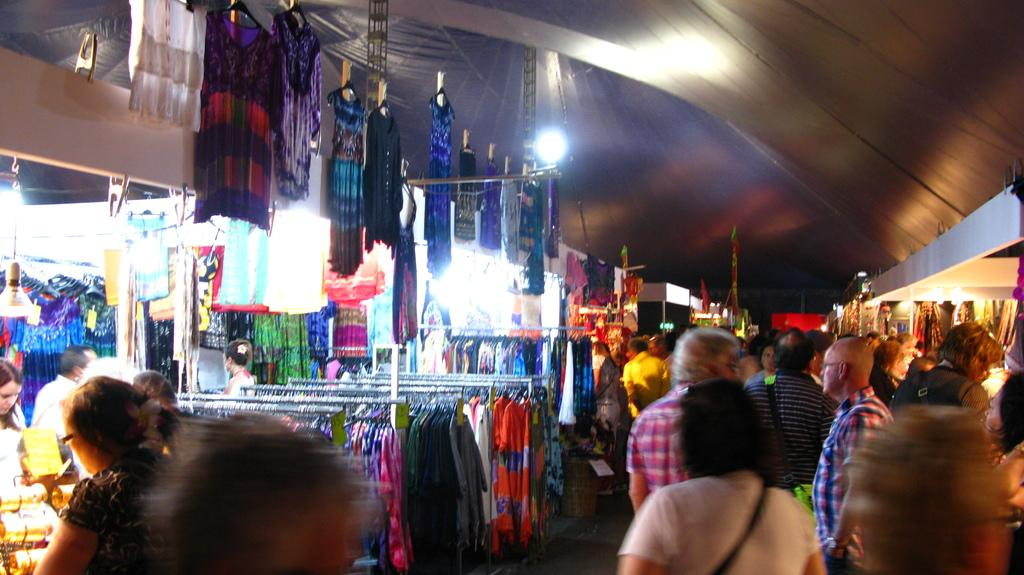What type of structures are present in the image? There are stalls and closets in the image. What provides shelter in the image? There is a roof for shelter in the image. What allows for visibility in the image? There are lights visible in the image. Who is present in the image? There are people present in the image. Can you tell me how many vases are displayed on the stalls in the image? There is no mention of vases in the image; the focus is on stalls, closets, and people. Are there any mice visible in the image? There is no mention of mice in the image; the focus is on the structures, lights, and people. 